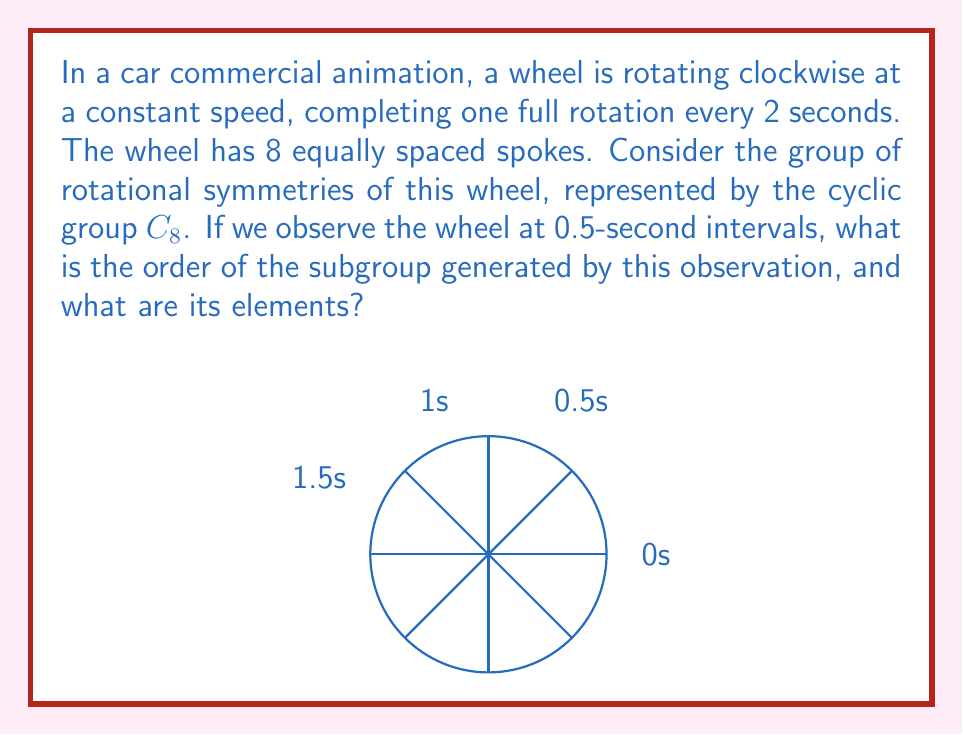Teach me how to tackle this problem. Let's approach this step-by-step:

1) First, we need to understand what each 0.5-second interval represents in terms of rotation:
   - In 2 seconds, the wheel makes a full 360° rotation
   - So in 0.5 seconds, it rotates by 90° (quarter turn)

2) The group $C_8$ represents all possible rotations of the 8-spoked wheel. Its elements can be represented as powers of a generator $r$, where $r$ is a 45° rotation:
   $C_8 = \{e, r, r^2, r^3, r^4, r^5, r^6, r^7\}$

3) Our observation at 0.5-second intervals corresponds to applying $r^2$ (90° rotation) repeatedly:
   - At 0s: $e$ (identity)
   - At 0.5s: $r^2$
   - At 1s: $r^4$
   - At 1.5s: $r^6$
   - At 2s: $r^8 = e$ (back to starting position)

4) The subgroup generated by this observation is $\langle r^2 \rangle$, which consists of:
   $\{e, r^2, r^4, r^6\}$

5) To find the order of this subgroup, we count its elements. There are 4 distinct elements.

Therefore, the subgroup $\langle r^2 \rangle$ has order 4, and its elements are $\{e, r^2, r^4, r^6\}$.
Answer: Order: 4; Elements: $\{e, r^2, r^4, r^6\}$ 